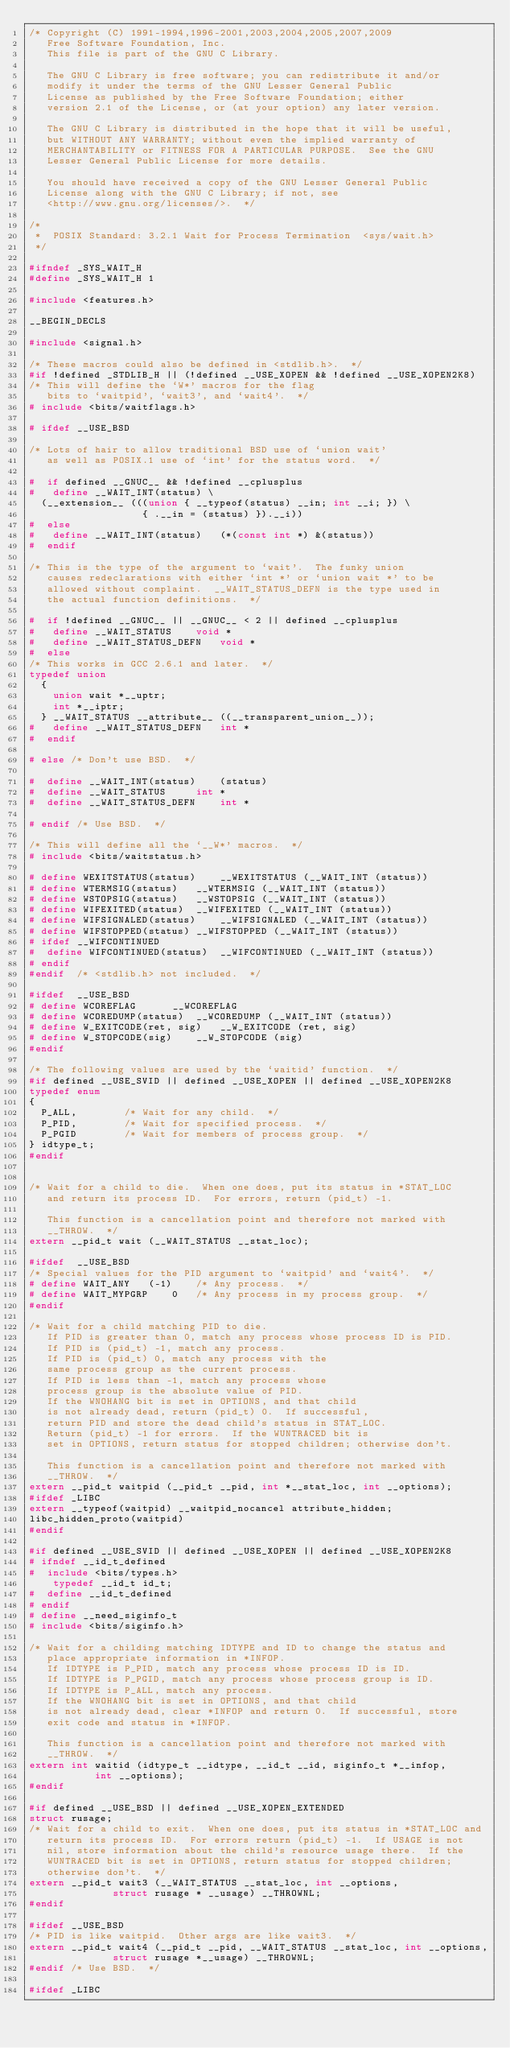<code> <loc_0><loc_0><loc_500><loc_500><_C_>/* Copyright (C) 1991-1994,1996-2001,2003,2004,2005,2007,2009
   Free Software Foundation, Inc.
   This file is part of the GNU C Library.

   The GNU C Library is free software; you can redistribute it and/or
   modify it under the terms of the GNU Lesser General Public
   License as published by the Free Software Foundation; either
   version 2.1 of the License, or (at your option) any later version.

   The GNU C Library is distributed in the hope that it will be useful,
   but WITHOUT ANY WARRANTY; without even the implied warranty of
   MERCHANTABILITY or FITNESS FOR A PARTICULAR PURPOSE.  See the GNU
   Lesser General Public License for more details.

   You should have received a copy of the GNU Lesser General Public
   License along with the GNU C Library; if not, see
   <http://www.gnu.org/licenses/>.  */

/*
 *	POSIX Standard: 3.2.1 Wait for Process Termination	<sys/wait.h>
 */

#ifndef	_SYS_WAIT_H
#define	_SYS_WAIT_H	1

#include <features.h>

__BEGIN_DECLS

#include <signal.h>

/* These macros could also be defined in <stdlib.h>.  */
#if !defined _STDLIB_H || (!defined __USE_XOPEN && !defined __USE_XOPEN2K8)
/* This will define the `W*' macros for the flag
   bits to `waitpid', `wait3', and `wait4'.  */
# include <bits/waitflags.h>

# ifdef	__USE_BSD

/* Lots of hair to allow traditional BSD use of `union wait'
   as well as POSIX.1 use of `int' for the status word.  */

#  if defined __GNUC__ && !defined __cplusplus
#   define __WAIT_INT(status) \
  (__extension__ (((union { __typeof(status) __in; int __i; }) \
                   { .__in = (status) }).__i))
#  else
#   define __WAIT_INT(status)	(*(const int *) &(status))
#  endif

/* This is the type of the argument to `wait'.  The funky union
   causes redeclarations with either `int *' or `union wait *' to be
   allowed without complaint.  __WAIT_STATUS_DEFN is the type used in
   the actual function definitions.  */

#  if !defined __GNUC__ || __GNUC__ < 2 || defined __cplusplus
#   define __WAIT_STATUS	void *
#   define __WAIT_STATUS_DEFN	void *
#  else
/* This works in GCC 2.6.1 and later.  */
typedef union
  {
    union wait *__uptr;
    int *__iptr;
  } __WAIT_STATUS __attribute__ ((__transparent_union__));
#   define __WAIT_STATUS_DEFN	int *
#  endif

# else /* Don't use BSD.  */

#  define __WAIT_INT(status)	(status)
#  define __WAIT_STATUS		int *
#  define __WAIT_STATUS_DEFN	int *

# endif /* Use BSD.  */

/* This will define all the `__W*' macros.  */
# include <bits/waitstatus.h>

# define WEXITSTATUS(status)	__WEXITSTATUS (__WAIT_INT (status))
# define WTERMSIG(status)	__WTERMSIG (__WAIT_INT (status))
# define WSTOPSIG(status)	__WSTOPSIG (__WAIT_INT (status))
# define WIFEXITED(status)	__WIFEXITED (__WAIT_INT (status))
# define WIFSIGNALED(status)	__WIFSIGNALED (__WAIT_INT (status))
# define WIFSTOPPED(status)	__WIFSTOPPED (__WAIT_INT (status))
# ifdef __WIFCONTINUED
#  define WIFCONTINUED(status)	__WIFCONTINUED (__WAIT_INT (status))
# endif
#endif	/* <stdlib.h> not included.  */

#ifdef	__USE_BSD
# define WCOREFLAG		__WCOREFLAG
# define WCOREDUMP(status)	__WCOREDUMP (__WAIT_INT (status))
# define W_EXITCODE(ret, sig)	__W_EXITCODE (ret, sig)
# define W_STOPCODE(sig)	__W_STOPCODE (sig)
#endif

/* The following values are used by the `waitid' function.  */
#if defined __USE_SVID || defined __USE_XOPEN || defined __USE_XOPEN2K8
typedef enum
{
  P_ALL,		/* Wait for any child.  */
  P_PID,		/* Wait for specified process.  */
  P_PGID		/* Wait for members of process group.  */
} idtype_t;
#endif


/* Wait for a child to die.  When one does, put its status in *STAT_LOC
   and return its process ID.  For errors, return (pid_t) -1.

   This function is a cancellation point and therefore not marked with
   __THROW.  */
extern __pid_t wait (__WAIT_STATUS __stat_loc);

#ifdef	__USE_BSD
/* Special values for the PID argument to `waitpid' and `wait4'.  */
# define WAIT_ANY	(-1)	/* Any process.  */
# define WAIT_MYPGRP	0	/* Any process in my process group.  */
#endif

/* Wait for a child matching PID to die.
   If PID is greater than 0, match any process whose process ID is PID.
   If PID is (pid_t) -1, match any process.
   If PID is (pid_t) 0, match any process with the
   same process group as the current process.
   If PID is less than -1, match any process whose
   process group is the absolute value of PID.
   If the WNOHANG bit is set in OPTIONS, and that child
   is not already dead, return (pid_t) 0.  If successful,
   return PID and store the dead child's status in STAT_LOC.
   Return (pid_t) -1 for errors.  If the WUNTRACED bit is
   set in OPTIONS, return status for stopped children; otherwise don't.

   This function is a cancellation point and therefore not marked with
   __THROW.  */
extern __pid_t waitpid (__pid_t __pid, int *__stat_loc, int __options);
#ifdef _LIBC
extern __typeof(waitpid) __waitpid_nocancel attribute_hidden;
libc_hidden_proto(waitpid)
#endif

#if defined __USE_SVID || defined __USE_XOPEN || defined __USE_XOPEN2K8
# ifndef __id_t_defined
#  include <bits/types.h>
	typedef __id_t id_t;
#  define __id_t_defined
# endif
# define __need_siginfo_t
# include <bits/siginfo.h>

/* Wait for a childing matching IDTYPE and ID to change the status and
   place appropriate information in *INFOP.
   If IDTYPE is P_PID, match any process whose process ID is ID.
   If IDTYPE is P_PGID, match any process whose process group is ID.
   If IDTYPE is P_ALL, match any process.
   If the WNOHANG bit is set in OPTIONS, and that child
   is not already dead, clear *INFOP and return 0.  If successful, store
   exit code and status in *INFOP.

   This function is a cancellation point and therefore not marked with
   __THROW.  */
extern int waitid (idtype_t __idtype, __id_t __id, siginfo_t *__infop,
		   int __options);
#endif

#if defined __USE_BSD || defined __USE_XOPEN_EXTENDED
struct rusage;
/* Wait for a child to exit.  When one does, put its status in *STAT_LOC and
   return its process ID.  For errors return (pid_t) -1.  If USAGE is not
   nil, store information about the child's resource usage there.  If the
   WUNTRACED bit is set in OPTIONS, return status for stopped children;
   otherwise don't.  */
extern __pid_t wait3 (__WAIT_STATUS __stat_loc, int __options,
		      struct rusage * __usage) __THROWNL;
#endif

#ifdef __USE_BSD
/* PID is like waitpid.  Other args are like wait3.  */
extern __pid_t wait4 (__pid_t __pid, __WAIT_STATUS __stat_loc, int __options,
		      struct rusage *__usage) __THROWNL;
#endif /* Use BSD.  */

#ifdef _LIBC</code> 